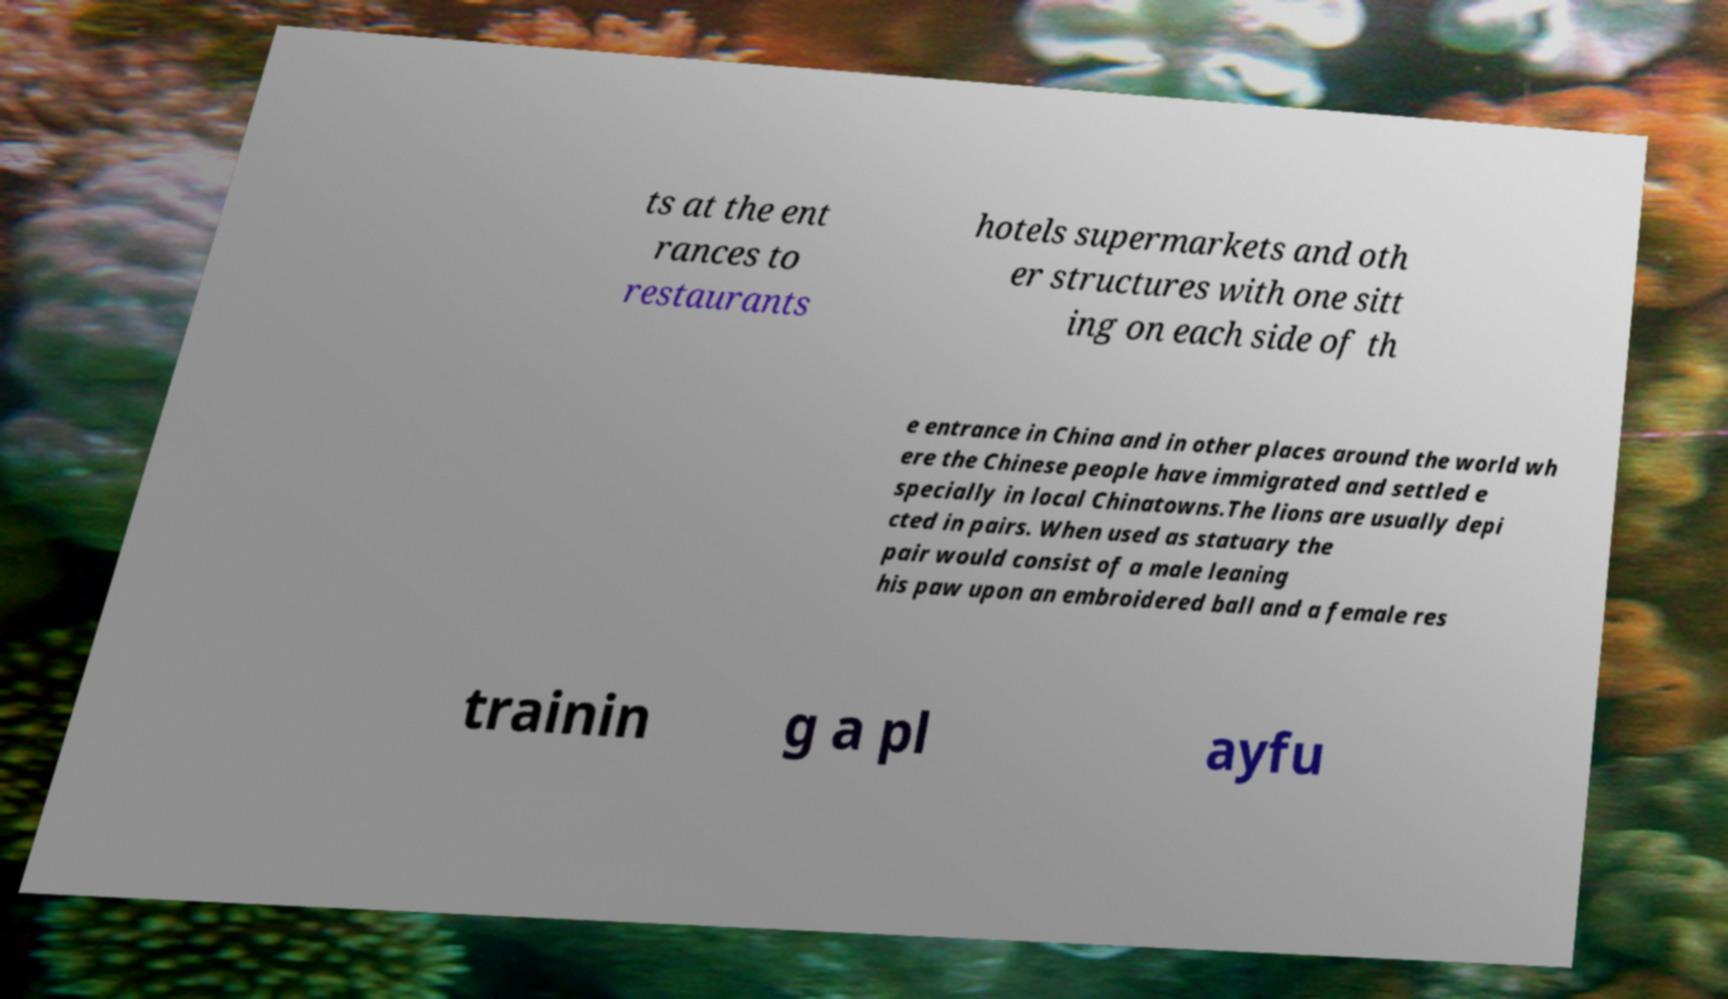Please read and relay the text visible in this image. What does it say? ts at the ent rances to restaurants hotels supermarkets and oth er structures with one sitt ing on each side of th e entrance in China and in other places around the world wh ere the Chinese people have immigrated and settled e specially in local Chinatowns.The lions are usually depi cted in pairs. When used as statuary the pair would consist of a male leaning his paw upon an embroidered ball and a female res trainin g a pl ayfu 